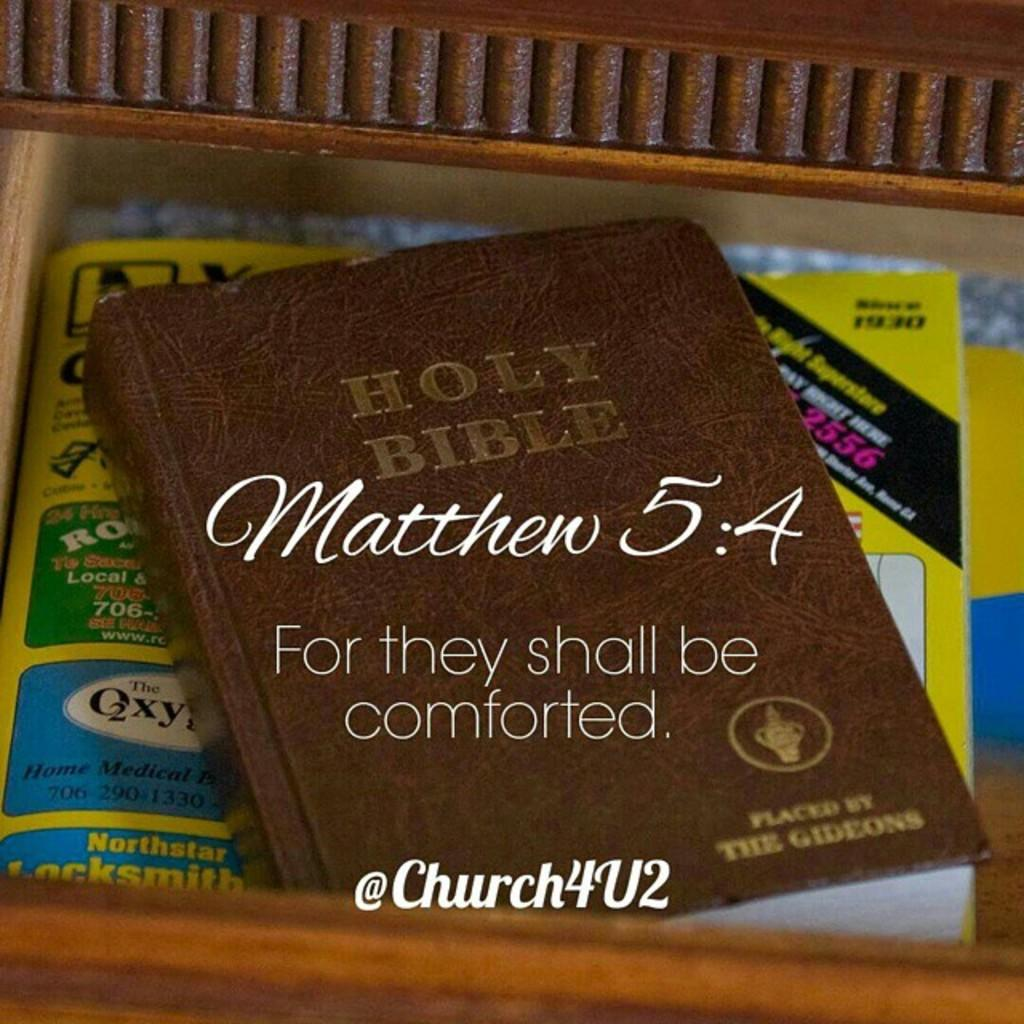<image>
Render a clear and concise summary of the photo. The Holy Bible is shown with a brown cover. 